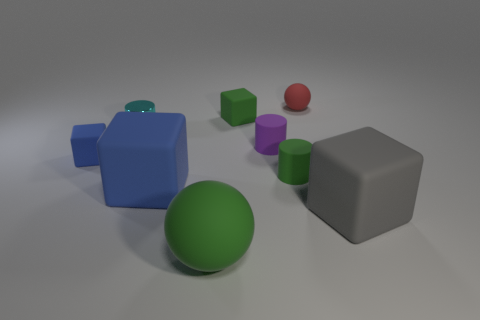What number of tiny things are there?
Your answer should be very brief. 6. The cylinder that is left of the green thing that is behind the tiny thing that is in front of the tiny blue matte thing is made of what material?
Ensure brevity in your answer.  Metal. There is a big cube right of the purple cylinder; how many matte things are in front of it?
Offer a very short reply. 1. What is the color of the other large matte object that is the same shape as the big gray rubber thing?
Your response must be concise. Blue. Is the material of the large green ball the same as the cyan cylinder?
Make the answer very short. No. What number of cubes are either large brown matte objects or tiny red things?
Keep it short and to the point. 0. There is a rubber thing that is on the right side of the matte ball behind the blue rubber object in front of the tiny blue matte block; what is its size?
Your response must be concise. Large. There is another purple object that is the same shape as the metallic object; what is its size?
Your answer should be compact. Small. There is a red rubber thing; how many tiny cyan shiny objects are to the right of it?
Give a very brief answer. 0. There is a rubber cube behind the small cyan metallic cylinder; does it have the same color as the large ball?
Make the answer very short. Yes. 